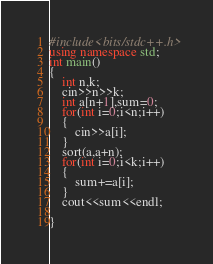Convert code to text. <code><loc_0><loc_0><loc_500><loc_500><_C++_>#include<bits/stdc++.h>
using namespace std;
int main()
{
    int n,k;
    cin>>n>>k;
    int a[n+1],sum=0;
    for(int i=0;i<n;i++)
    {
        cin>>a[i];
    }
    sort(a,a+n);
    for(int i=0;i<k;i++)
    {
        sum+=a[i];
    }
    cout<<sum<<endl;

}
</code> 